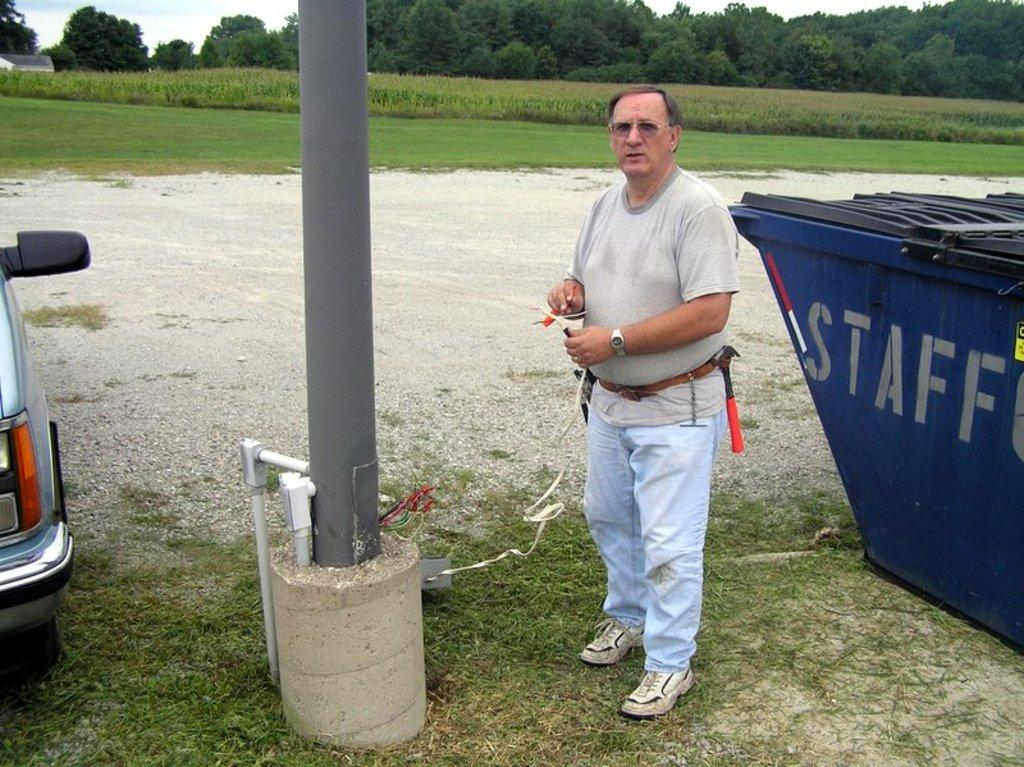<image>
Present a compact description of the photo's key features. A man is standing beside a blue dumpster marked Staff. 